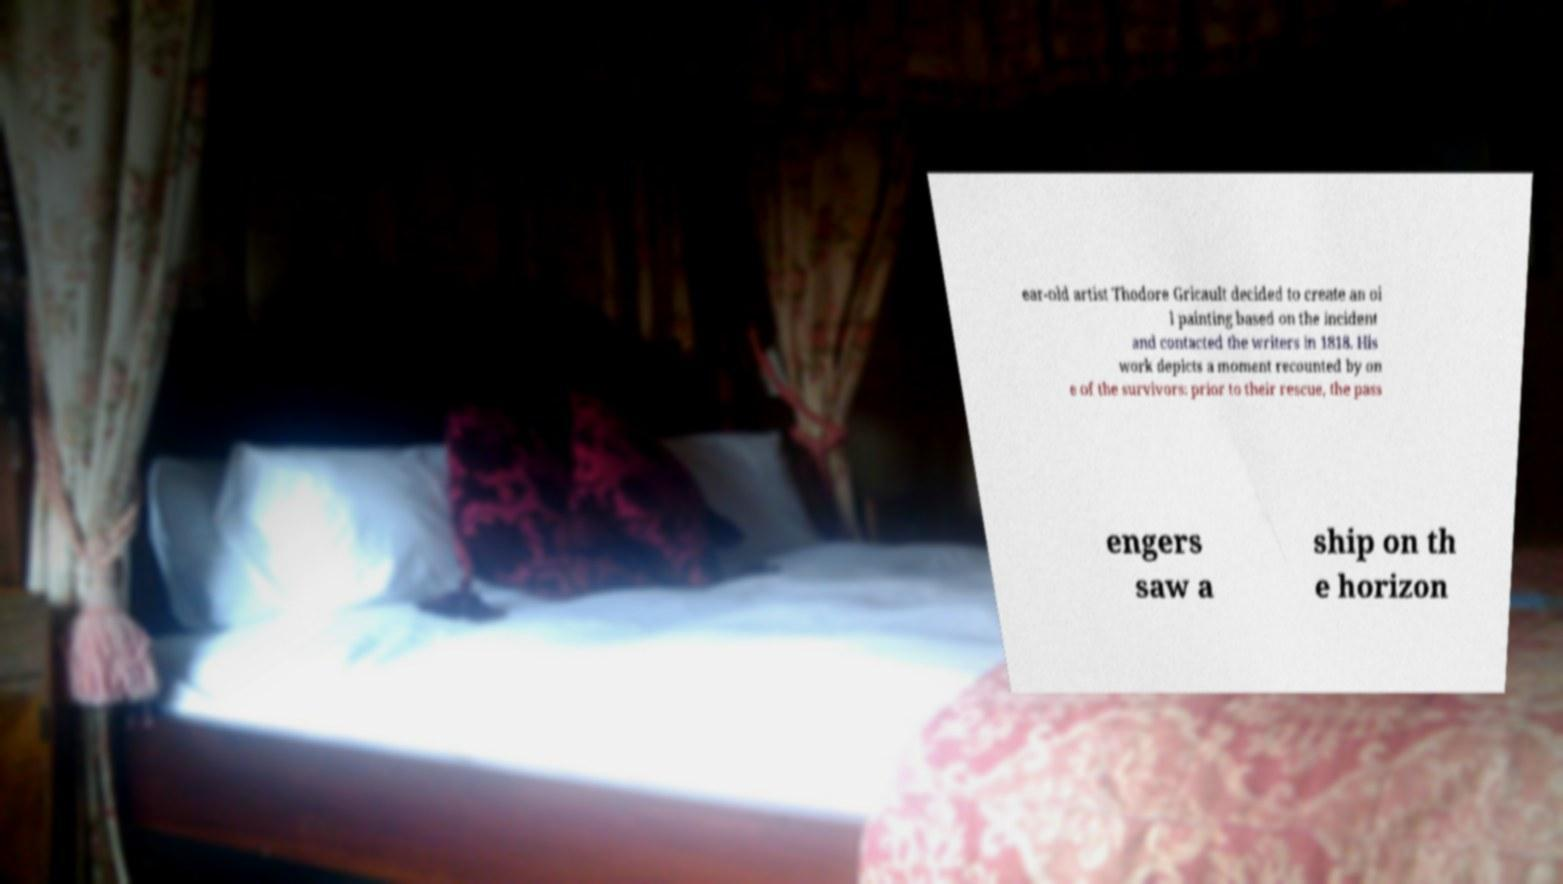Could you extract and type out the text from this image? ear-old artist Thodore Gricault decided to create an oi l painting based on the incident and contacted the writers in 1818. His work depicts a moment recounted by on e of the survivors: prior to their rescue, the pass engers saw a ship on th e horizon 